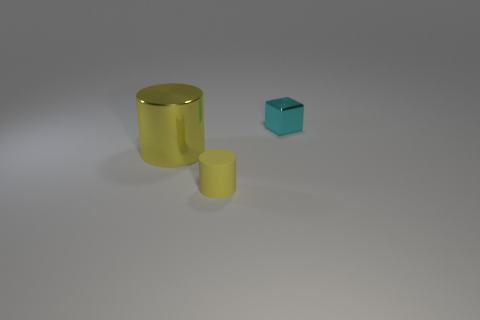Add 1 metal cubes. How many objects exist? 4 Subtract all cylinders. How many objects are left? 1 Add 3 cyan shiny objects. How many cyan shiny objects exist? 4 Subtract 0 green cylinders. How many objects are left? 3 Subtract all green balls. Subtract all tiny cyan metal cubes. How many objects are left? 2 Add 2 big metal objects. How many big metal objects are left? 3 